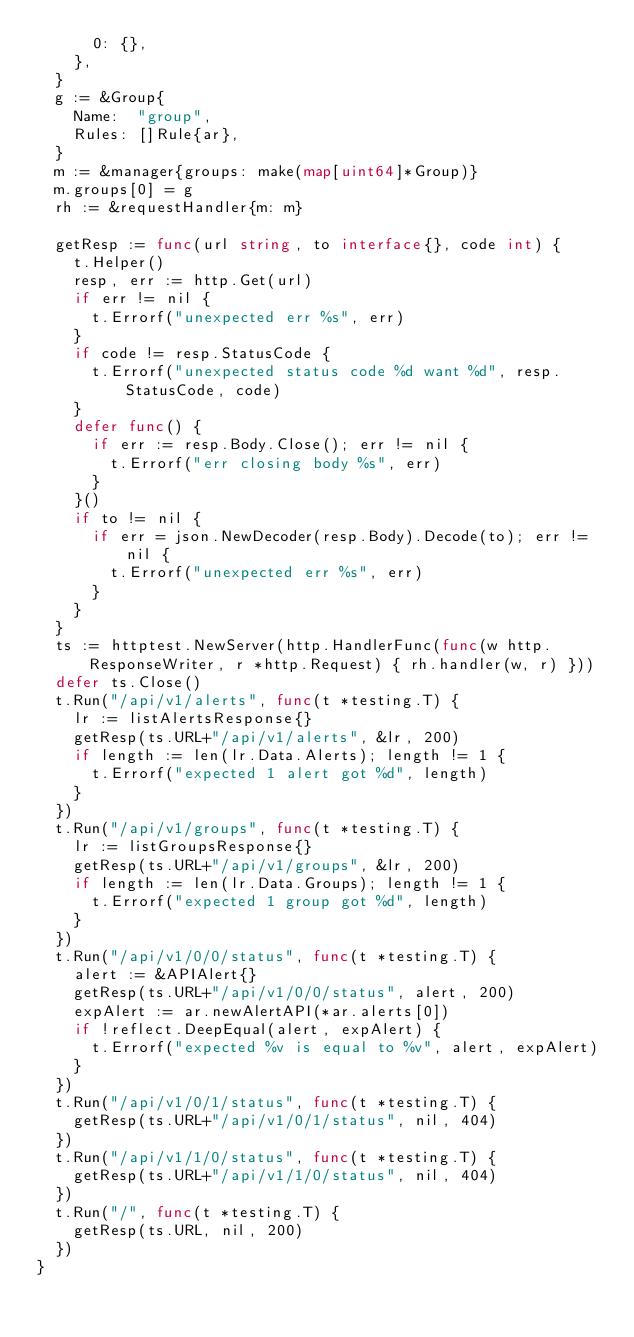Convert code to text. <code><loc_0><loc_0><loc_500><loc_500><_Go_>			0: {},
		},
	}
	g := &Group{
		Name:  "group",
		Rules: []Rule{ar},
	}
	m := &manager{groups: make(map[uint64]*Group)}
	m.groups[0] = g
	rh := &requestHandler{m: m}

	getResp := func(url string, to interface{}, code int) {
		t.Helper()
		resp, err := http.Get(url)
		if err != nil {
			t.Errorf("unexpected err %s", err)
		}
		if code != resp.StatusCode {
			t.Errorf("unexpected status code %d want %d", resp.StatusCode, code)
		}
		defer func() {
			if err := resp.Body.Close(); err != nil {
				t.Errorf("err closing body %s", err)
			}
		}()
		if to != nil {
			if err = json.NewDecoder(resp.Body).Decode(to); err != nil {
				t.Errorf("unexpected err %s", err)
			}
		}
	}
	ts := httptest.NewServer(http.HandlerFunc(func(w http.ResponseWriter, r *http.Request) { rh.handler(w, r) }))
	defer ts.Close()
	t.Run("/api/v1/alerts", func(t *testing.T) {
		lr := listAlertsResponse{}
		getResp(ts.URL+"/api/v1/alerts", &lr, 200)
		if length := len(lr.Data.Alerts); length != 1 {
			t.Errorf("expected 1 alert got %d", length)
		}
	})
	t.Run("/api/v1/groups", func(t *testing.T) {
		lr := listGroupsResponse{}
		getResp(ts.URL+"/api/v1/groups", &lr, 200)
		if length := len(lr.Data.Groups); length != 1 {
			t.Errorf("expected 1 group got %d", length)
		}
	})
	t.Run("/api/v1/0/0/status", func(t *testing.T) {
		alert := &APIAlert{}
		getResp(ts.URL+"/api/v1/0/0/status", alert, 200)
		expAlert := ar.newAlertAPI(*ar.alerts[0])
		if !reflect.DeepEqual(alert, expAlert) {
			t.Errorf("expected %v is equal to %v", alert, expAlert)
		}
	})
	t.Run("/api/v1/0/1/status", func(t *testing.T) {
		getResp(ts.URL+"/api/v1/0/1/status", nil, 404)
	})
	t.Run("/api/v1/1/0/status", func(t *testing.T) {
		getResp(ts.URL+"/api/v1/1/0/status", nil, 404)
	})
	t.Run("/", func(t *testing.T) {
		getResp(ts.URL, nil, 200)
	})
}
</code> 